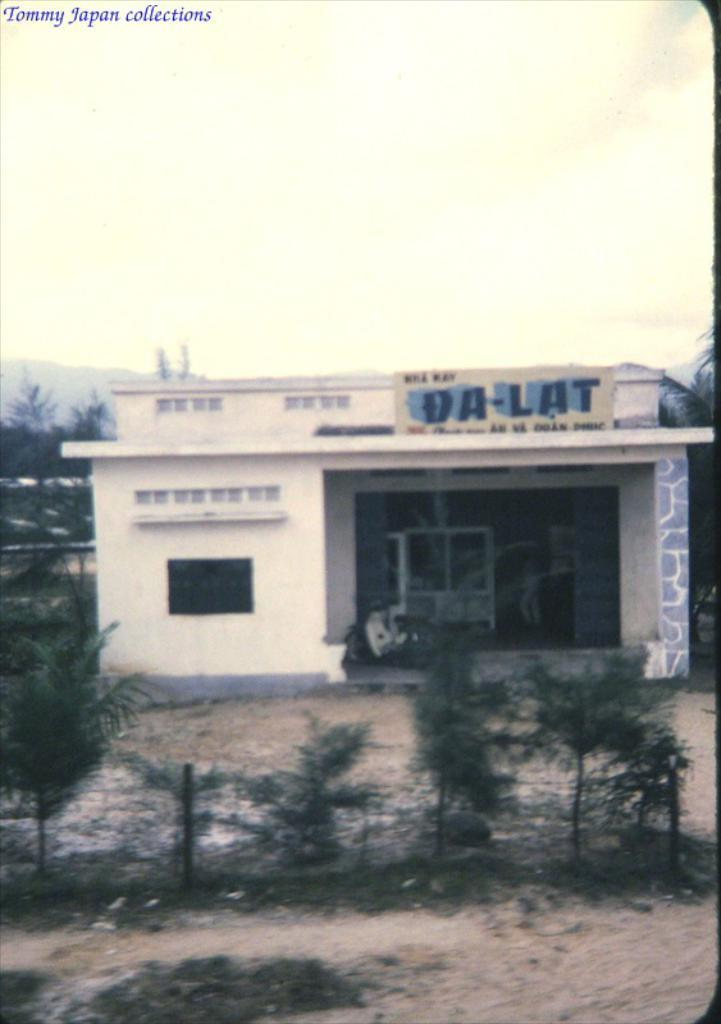What type of establishment is depicted in the image? There is a shop in the image. What type of vegetation is present in the image? There are green trees in the image. What is visible at the top of the image? The sky is visible at the top of the image. What type of boot is the judge wearing in the image? There is no judge or boot present in the image. What type of trade is being conducted in the image? There is no indication of any trade being conducted in the image. 